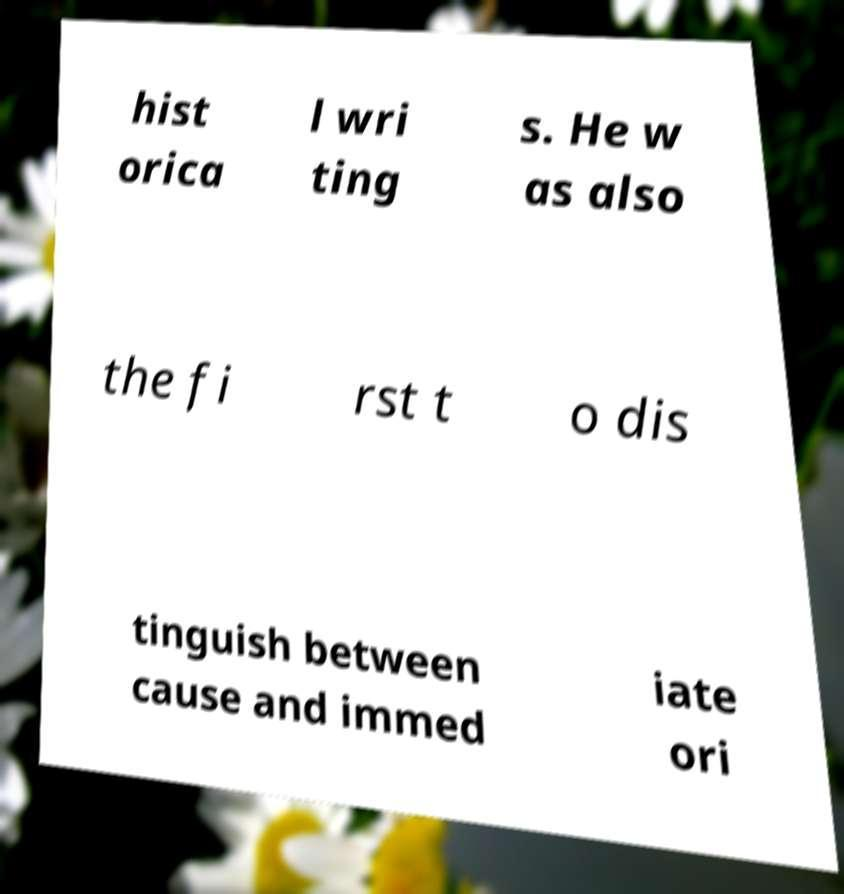Please read and relay the text visible in this image. What does it say? hist orica l wri ting s. He w as also the fi rst t o dis tinguish between cause and immed iate ori 